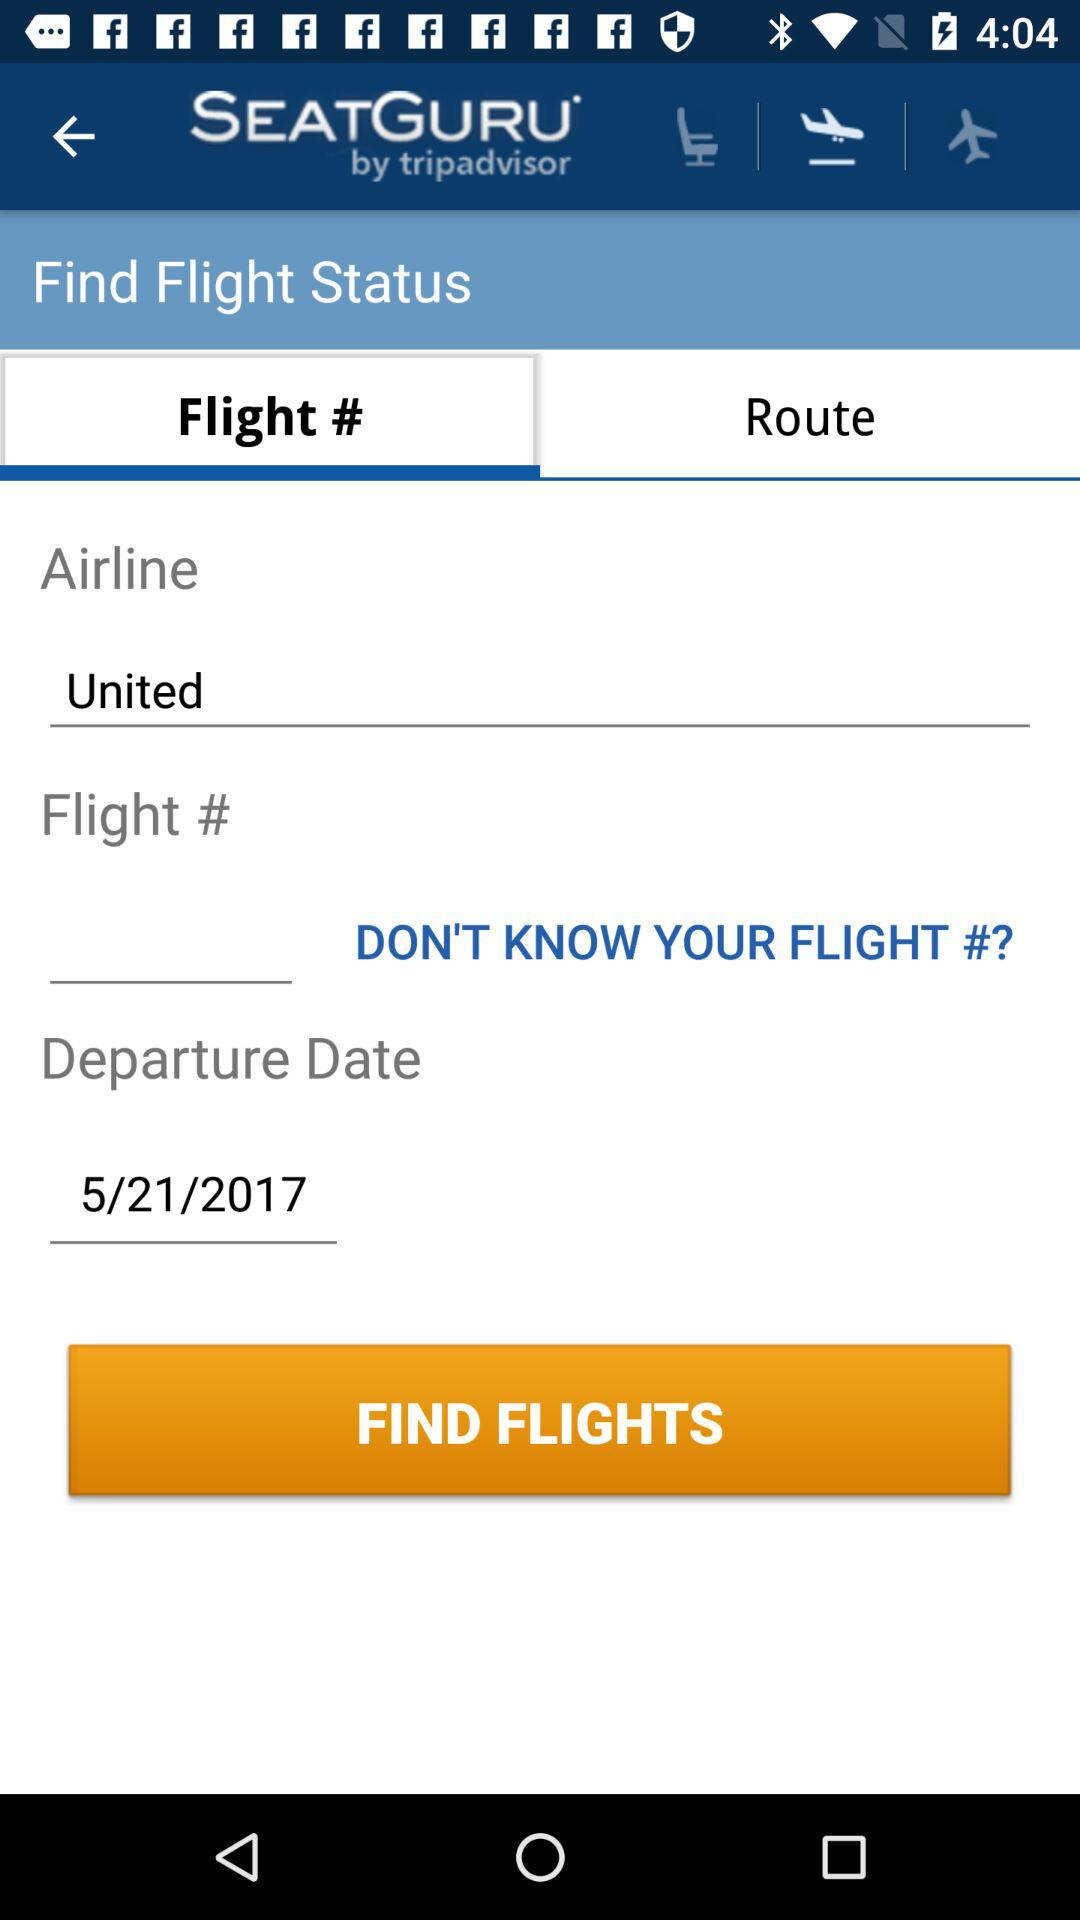What's the departure date? The departure date is May 21, 2017. 